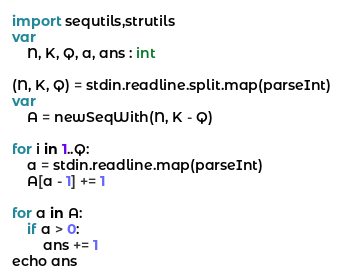<code> <loc_0><loc_0><loc_500><loc_500><_Nim_>import sequtils,strutils
var
    N, K, Q, a, ans : int

(N, K, Q) = stdin.readline.split.map(parseInt)
var
    A = newSeqWith(N, K - Q)

for i in 1..Q:
    a = stdin.readline.map(parseInt)
    A[a - 1] += 1

for a in A:
    if a > 0:
        ans += 1
echo ans


</code> 